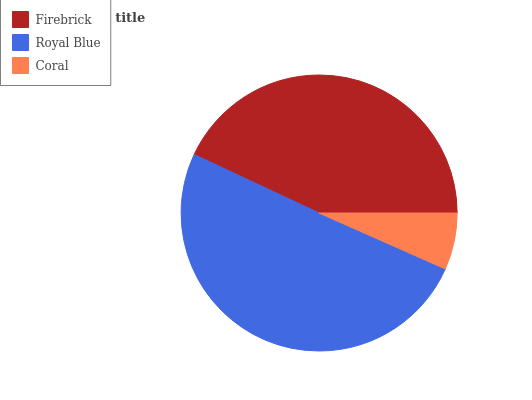Is Coral the minimum?
Answer yes or no. Yes. Is Royal Blue the maximum?
Answer yes or no. Yes. Is Royal Blue the minimum?
Answer yes or no. No. Is Coral the maximum?
Answer yes or no. No. Is Royal Blue greater than Coral?
Answer yes or no. Yes. Is Coral less than Royal Blue?
Answer yes or no. Yes. Is Coral greater than Royal Blue?
Answer yes or no. No. Is Royal Blue less than Coral?
Answer yes or no. No. Is Firebrick the high median?
Answer yes or no. Yes. Is Firebrick the low median?
Answer yes or no. Yes. Is Coral the high median?
Answer yes or no. No. Is Coral the low median?
Answer yes or no. No. 